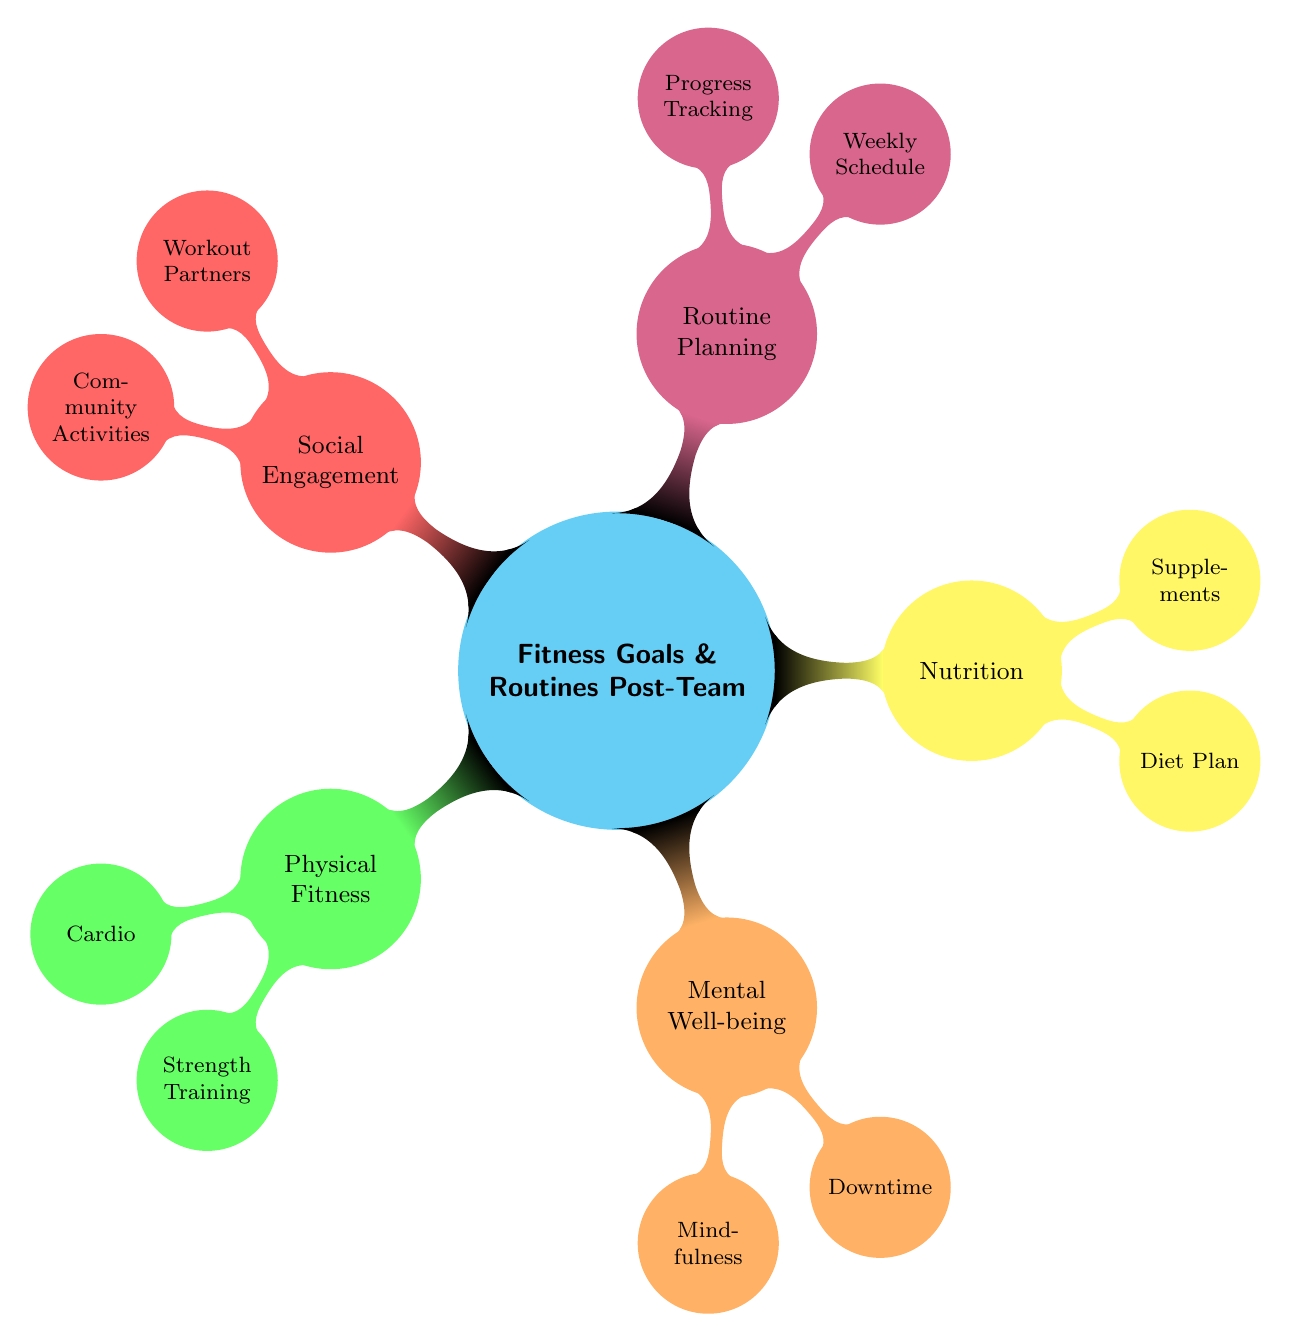What are the two main categories under Physical Fitness? The diagram shows two main categories under Physical Fitness, which are Cardio and Strength Training. This can be found in the first child node of the Fitness Goals section.
Answer: Cardio, Strength Training How many mindfulness practices are listed? In the Mental Well-being section, there are two mindfulness practices mentioned: Yoga and Meditation. The count of nodes under this category helps in determining this.
Answer: 2 Which category includes Supplements? The diagram indicates that Supplements are part of the Nutrition category. By examining the branches of the diagram, this relationship is established as Supplements is a child node under Nutrition.
Answer: Nutrition What is one Downtime Activity listed in the diagram? The diagram states that one of the Downtime Activities is Listening to Music, which is a child node under the Mental Well-being category.
Answer: Listening to Music Which fitness activity is mentioned under Social Engagement? The diagram indicates that Community Activities is one of the areas under Social Engagement, which implies it includes various activities related to fitness in a social context.
Answer: Community Activities What is the purpose of Progress Tracking in Routine Planning? The diagram organizes Routine Planning to include Progress Tracking, which suggests it's meant to monitor an individual’s fitness progress and may utilize tools such as fitness apps or journals.
Answer: Monitor fitness progress How many types of cardio exercises are listed? There are three types of cardio exercises mentioned in the diagram: Running, Cycling, and Swimming. This can be verified by counting the nodes under the Cardio child node.
Answer: 3 What relationship exists between Workout Partners and Community Activities? Both Workout Partners and Community Activities are elements under the Social Engagement category. This indicates they are related in promoting social fitness activities and connections.
Answer: Both under Social Engagement Which section includes Diet Plan? The Diet Plan is part of the Nutrition section, which is clearly labeled as a child node of the main Fitness Goals category.
Answer: Nutrition 